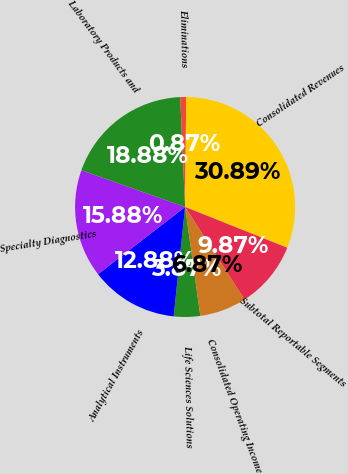Convert chart to OTSL. <chart><loc_0><loc_0><loc_500><loc_500><pie_chart><fcel>Life Sciences Solutions<fcel>Analytical Instruments<fcel>Specialty Diagnostics<fcel>Laboratory Products and<fcel>Eliminations<fcel>Consolidated Revenues<fcel>Subtotal Reportable Segments<fcel>Consolidated Operating Income<nl><fcel>3.87%<fcel>12.88%<fcel>15.88%<fcel>18.88%<fcel>0.87%<fcel>30.89%<fcel>9.87%<fcel>6.87%<nl></chart> 